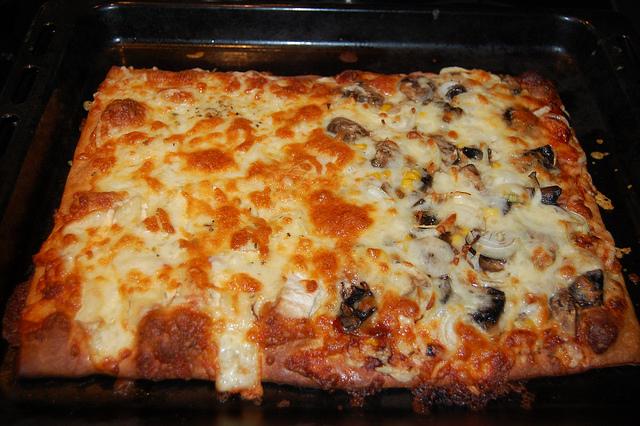Is the pizza cooked?
Quick response, please. Yes. Is this pizza square?
Answer briefly. Yes. What is cooking in the oven?
Write a very short answer. Pizza. Is it diet food?
Quick response, please. No. 